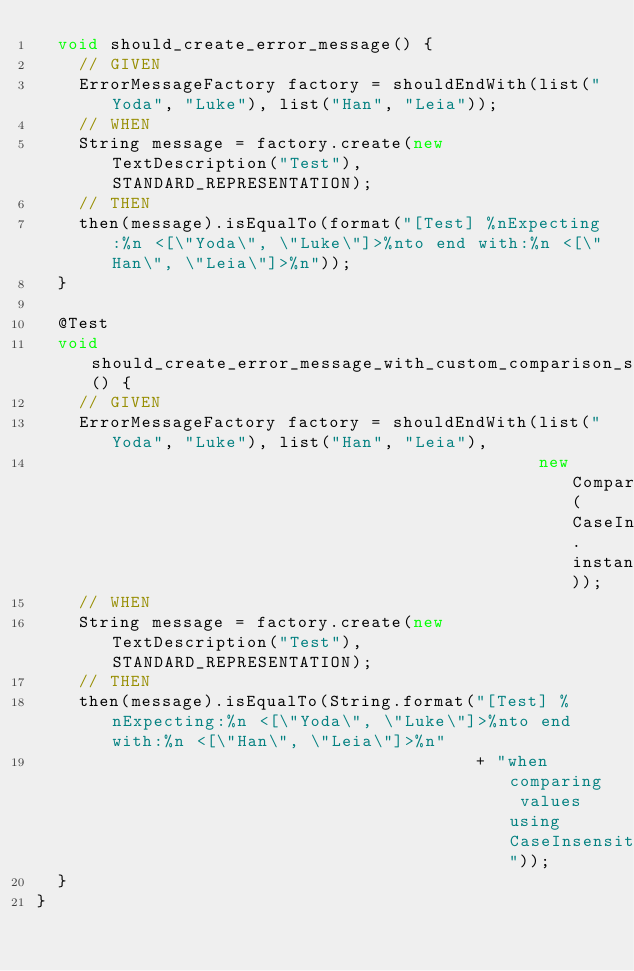<code> <loc_0><loc_0><loc_500><loc_500><_Java_>  void should_create_error_message() {
    // GIVEN
    ErrorMessageFactory factory = shouldEndWith(list("Yoda", "Luke"), list("Han", "Leia"));
    // WHEN
    String message = factory.create(new TextDescription("Test"), STANDARD_REPRESENTATION);
    // THEN
    then(message).isEqualTo(format("[Test] %nExpecting:%n <[\"Yoda\", \"Luke\"]>%nto end with:%n <[\"Han\", \"Leia\"]>%n"));
  }

  @Test
  void should_create_error_message_with_custom_comparison_strategy() {
    // GIVEN
    ErrorMessageFactory factory = shouldEndWith(list("Yoda", "Luke"), list("Han", "Leia"),
                                                new ComparatorBasedComparisonStrategy(CaseInsensitiveStringComparator.instance));
    // WHEN
    String message = factory.create(new TextDescription("Test"), STANDARD_REPRESENTATION);
    // THEN
    then(message).isEqualTo(String.format("[Test] %nExpecting:%n <[\"Yoda\", \"Luke\"]>%nto end with:%n <[\"Han\", \"Leia\"]>%n"
                                          + "when comparing values using CaseInsensitiveStringComparator"));
  }
}
</code> 